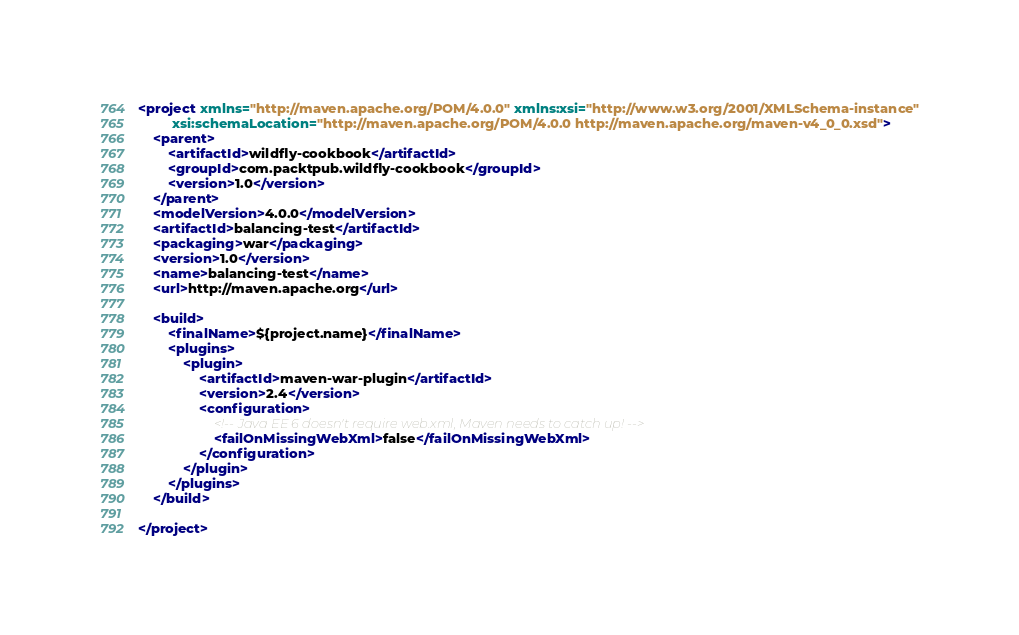<code> <loc_0><loc_0><loc_500><loc_500><_XML_><project xmlns="http://maven.apache.org/POM/4.0.0" xmlns:xsi="http://www.w3.org/2001/XMLSchema-instance"
         xsi:schemaLocation="http://maven.apache.org/POM/4.0.0 http://maven.apache.org/maven-v4_0_0.xsd">
    <parent>
        <artifactId>wildfly-cookbook</artifactId>
        <groupId>com.packtpub.wildfly-cookbook</groupId>
        <version>1.0</version>
    </parent>
    <modelVersion>4.0.0</modelVersion>
    <artifactId>balancing-test</artifactId>
    <packaging>war</packaging>
    <version>1.0</version>
    <name>balancing-test</name>
    <url>http://maven.apache.org</url>

    <build>
        <finalName>${project.name}</finalName>
        <plugins>
            <plugin>
                <artifactId>maven-war-plugin</artifactId>
                <version>2.4</version>
                <configuration>
                    <!-- Java EE 6 doesn't require web.xml, Maven needs to catch up! -->
                    <failOnMissingWebXml>false</failOnMissingWebXml>
                </configuration>
            </plugin>
        </plugins>
    </build>

</project>
</code> 